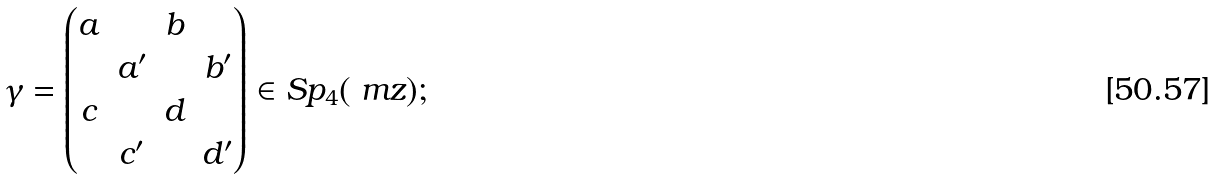<formula> <loc_0><loc_0><loc_500><loc_500>\gamma = \begin{pmatrix} a & & b & \\ & a ^ { \prime } & & b ^ { \prime } \\ c & & d & \\ & c ^ { \prime } & & d ^ { \prime } \end{pmatrix} \in S p _ { 4 } ( \ m z ) ;</formula> 